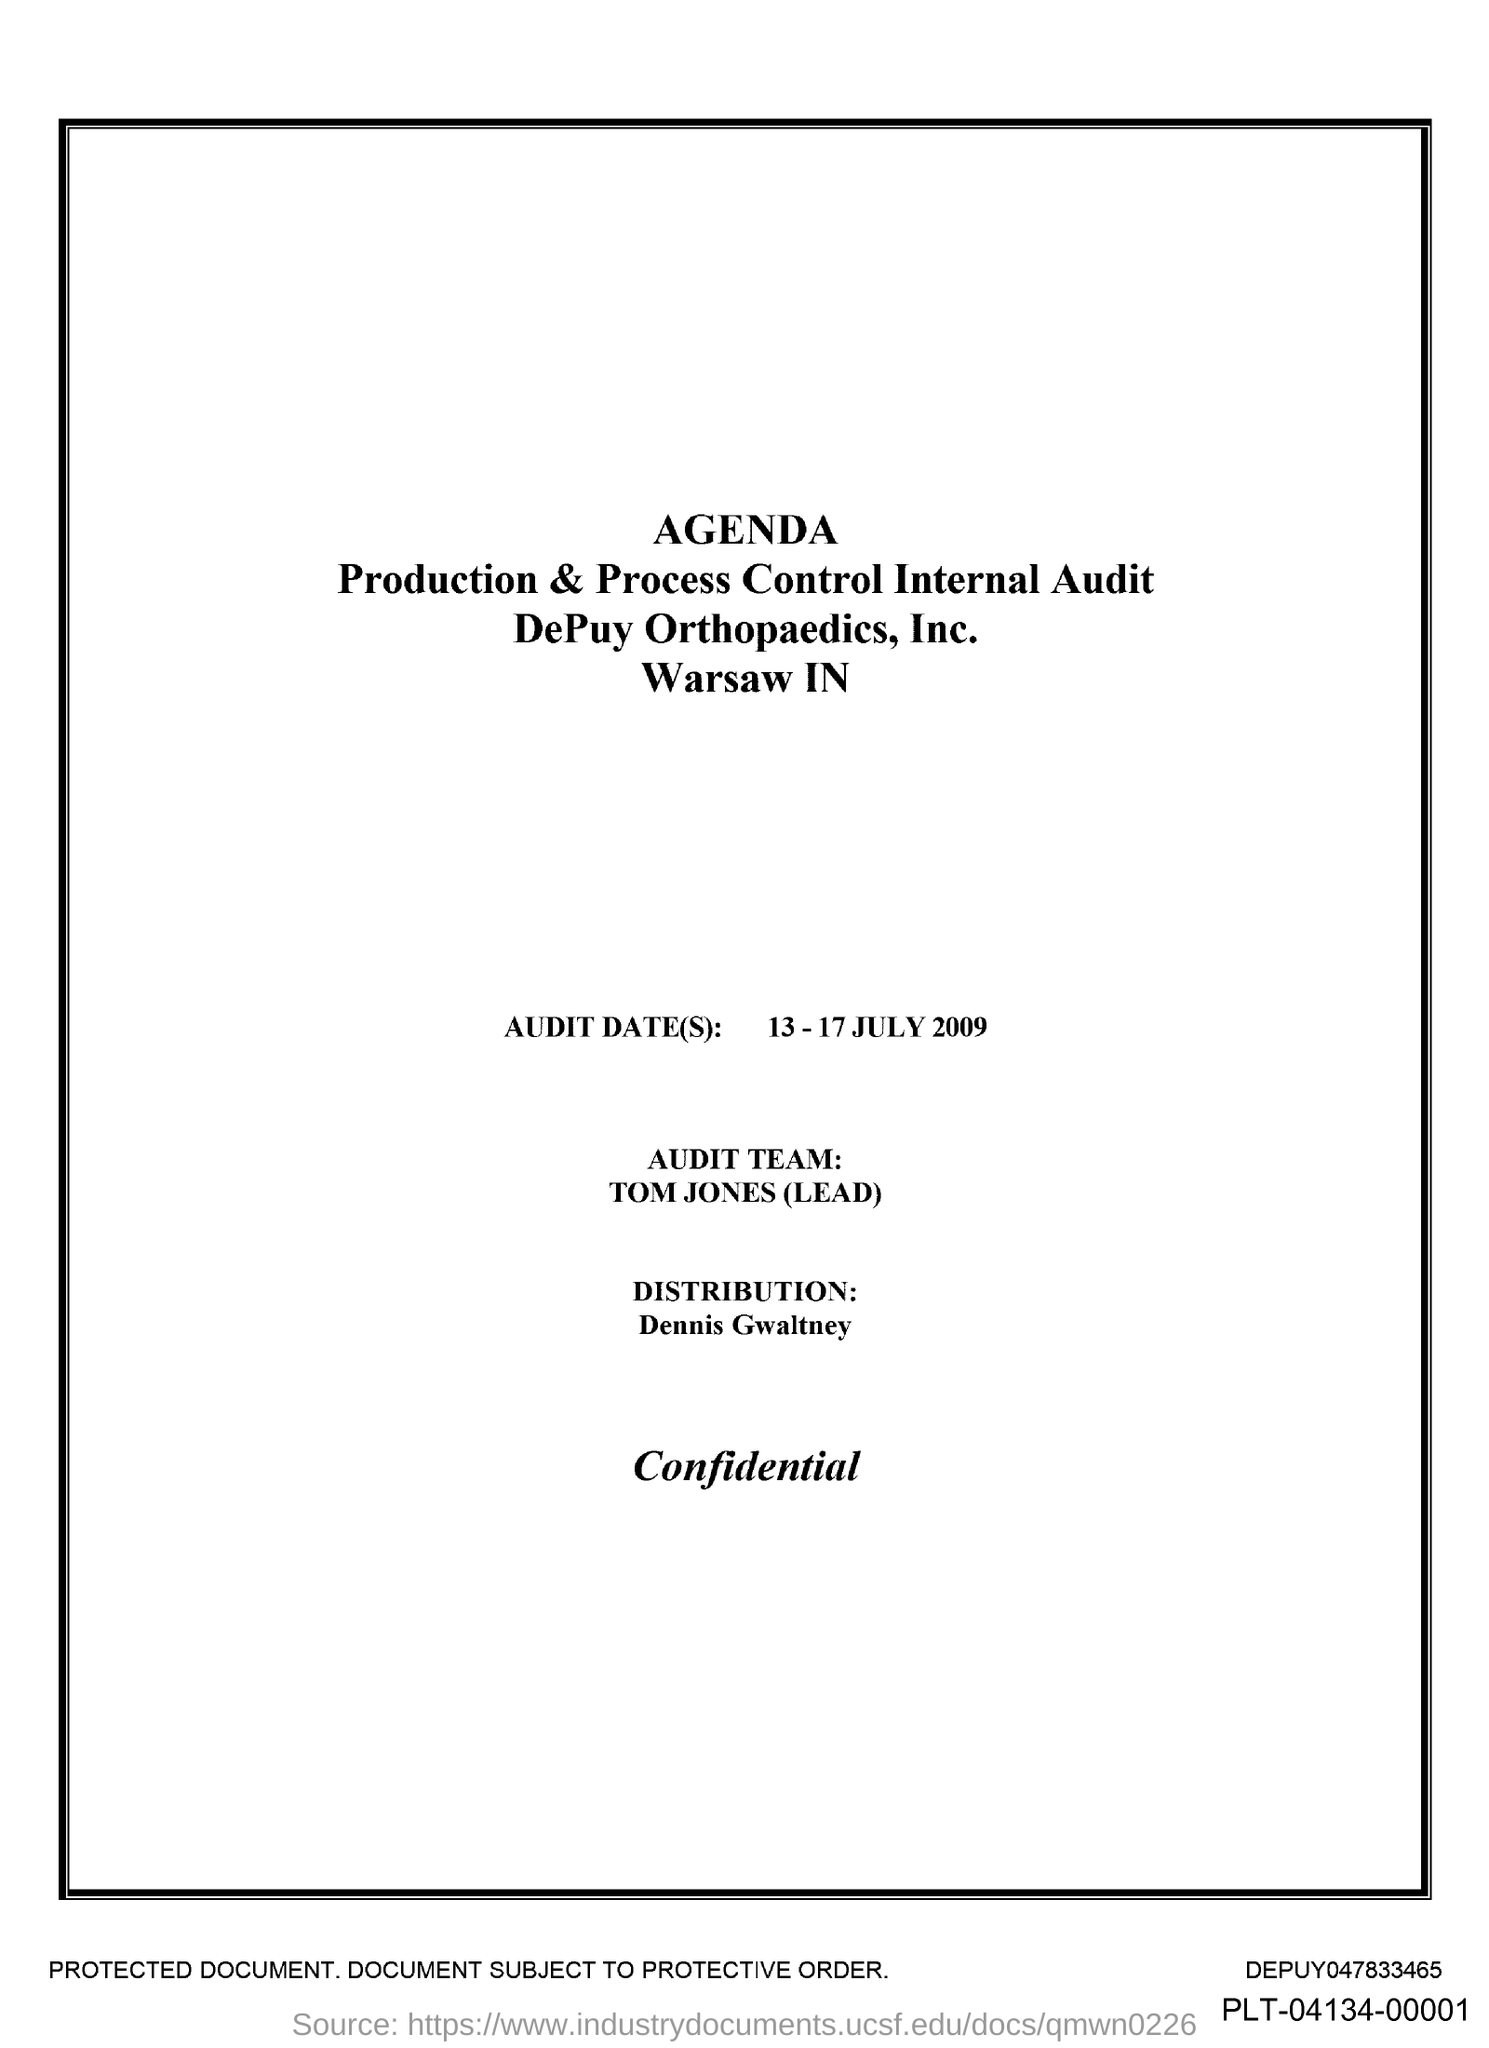Specify some key components in this picture. The person who led the audit team was Tom Jones. The audit dates mentioned are 13-17 July 2009. 